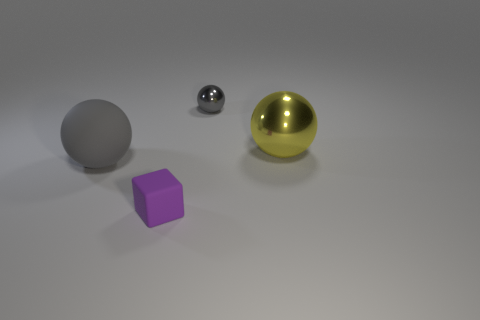Add 3 small metal objects. How many objects exist? 7 Subtract all large yellow balls. How many balls are left? 2 Subtract all brown blocks. How many gray spheres are left? 2 Subtract all yellow balls. How many balls are left? 2 Subtract all spheres. How many objects are left? 1 Subtract 0 green spheres. How many objects are left? 4 Subtract 3 spheres. How many spheres are left? 0 Subtract all red blocks. Subtract all cyan spheres. How many blocks are left? 1 Subtract all tiny gray cylinders. Subtract all gray spheres. How many objects are left? 2 Add 1 yellow metallic balls. How many yellow metallic balls are left? 2 